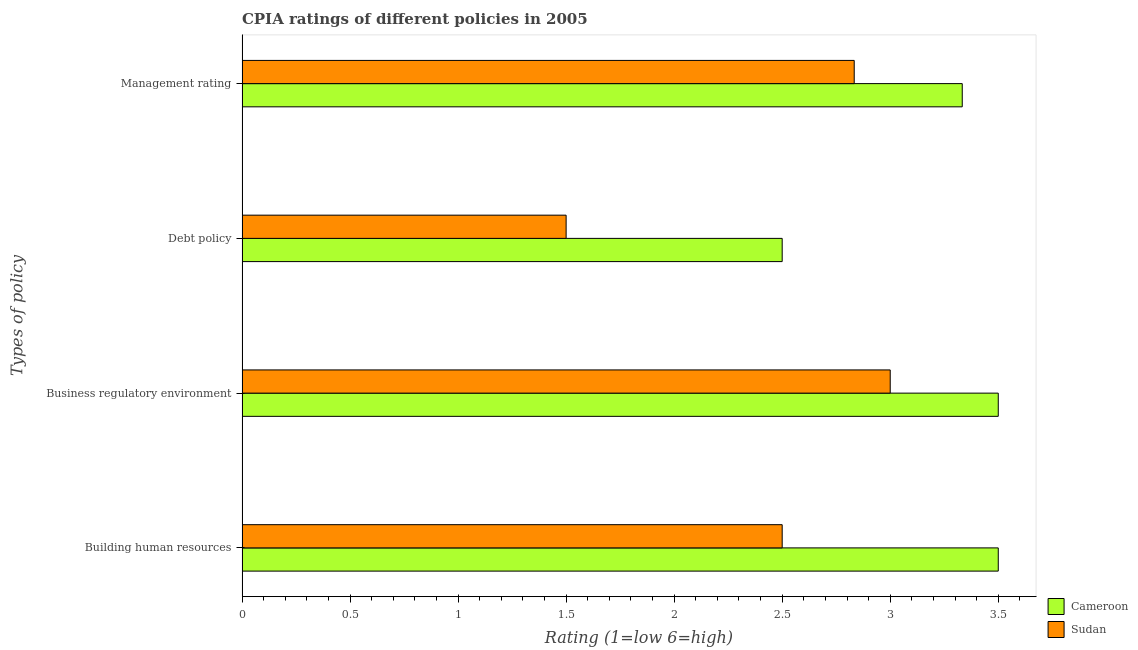How many different coloured bars are there?
Your answer should be very brief. 2. How many groups of bars are there?
Keep it short and to the point. 4. What is the label of the 3rd group of bars from the top?
Offer a terse response. Business regulatory environment. What is the cpia rating of debt policy in Cameroon?
Your response must be concise. 2.5. Across all countries, what is the maximum cpia rating of debt policy?
Offer a very short reply. 2.5. Across all countries, what is the minimum cpia rating of building human resources?
Ensure brevity in your answer.  2.5. In which country was the cpia rating of business regulatory environment maximum?
Your answer should be compact. Cameroon. In which country was the cpia rating of debt policy minimum?
Give a very brief answer. Sudan. What is the total cpia rating of business regulatory environment in the graph?
Provide a succinct answer. 6.5. What is the difference between the cpia rating of business regulatory environment in Sudan and that in Cameroon?
Make the answer very short. -0.5. What is the difference between the cpia rating of management in Sudan and the cpia rating of business regulatory environment in Cameroon?
Provide a succinct answer. -0.67. What is the average cpia rating of business regulatory environment per country?
Offer a very short reply. 3.25. In how many countries, is the cpia rating of business regulatory environment greater than 1.5 ?
Offer a terse response. 2. What is the ratio of the cpia rating of building human resources in Sudan to that in Cameroon?
Your response must be concise. 0.71. Is the difference between the cpia rating of management in Cameroon and Sudan greater than the difference between the cpia rating of debt policy in Cameroon and Sudan?
Give a very brief answer. No. What is the difference between the highest and the second highest cpia rating of business regulatory environment?
Offer a terse response. 0.5. What is the difference between the highest and the lowest cpia rating of building human resources?
Give a very brief answer. 1. Is the sum of the cpia rating of management in Cameroon and Sudan greater than the maximum cpia rating of business regulatory environment across all countries?
Your response must be concise. Yes. Is it the case that in every country, the sum of the cpia rating of management and cpia rating of business regulatory environment is greater than the sum of cpia rating of building human resources and cpia rating of debt policy?
Give a very brief answer. Yes. What does the 1st bar from the top in Business regulatory environment represents?
Your response must be concise. Sudan. What does the 1st bar from the bottom in Building human resources represents?
Ensure brevity in your answer.  Cameroon. How many countries are there in the graph?
Make the answer very short. 2. What is the difference between two consecutive major ticks on the X-axis?
Ensure brevity in your answer.  0.5. Are the values on the major ticks of X-axis written in scientific E-notation?
Give a very brief answer. No. Does the graph contain grids?
Provide a succinct answer. No. How are the legend labels stacked?
Your answer should be very brief. Vertical. What is the title of the graph?
Keep it short and to the point. CPIA ratings of different policies in 2005. What is the label or title of the Y-axis?
Ensure brevity in your answer.  Types of policy. What is the Rating (1=low 6=high) of Cameroon in Building human resources?
Provide a succinct answer. 3.5. What is the Rating (1=low 6=high) of Sudan in Building human resources?
Give a very brief answer. 2.5. What is the Rating (1=low 6=high) in Cameroon in Business regulatory environment?
Provide a succinct answer. 3.5. What is the Rating (1=low 6=high) of Cameroon in Debt policy?
Provide a succinct answer. 2.5. What is the Rating (1=low 6=high) in Sudan in Debt policy?
Give a very brief answer. 1.5. What is the Rating (1=low 6=high) in Cameroon in Management rating?
Your answer should be very brief. 3.33. What is the Rating (1=low 6=high) in Sudan in Management rating?
Provide a succinct answer. 2.83. Across all Types of policy, what is the maximum Rating (1=low 6=high) in Cameroon?
Offer a terse response. 3.5. Across all Types of policy, what is the minimum Rating (1=low 6=high) in Cameroon?
Offer a terse response. 2.5. Across all Types of policy, what is the minimum Rating (1=low 6=high) in Sudan?
Offer a terse response. 1.5. What is the total Rating (1=low 6=high) in Cameroon in the graph?
Ensure brevity in your answer.  12.83. What is the total Rating (1=low 6=high) of Sudan in the graph?
Provide a short and direct response. 9.83. What is the difference between the Rating (1=low 6=high) of Cameroon in Building human resources and that in Business regulatory environment?
Provide a succinct answer. 0. What is the difference between the Rating (1=low 6=high) in Cameroon in Building human resources and that in Management rating?
Provide a short and direct response. 0.17. What is the difference between the Rating (1=low 6=high) of Sudan in Building human resources and that in Management rating?
Your response must be concise. -0.33. What is the difference between the Rating (1=low 6=high) in Cameroon in Business regulatory environment and that in Debt policy?
Keep it short and to the point. 1. What is the difference between the Rating (1=low 6=high) of Sudan in Business regulatory environment and that in Debt policy?
Offer a terse response. 1.5. What is the difference between the Rating (1=low 6=high) in Cameroon in Business regulatory environment and that in Management rating?
Your answer should be very brief. 0.17. What is the difference between the Rating (1=low 6=high) of Sudan in Business regulatory environment and that in Management rating?
Your response must be concise. 0.17. What is the difference between the Rating (1=low 6=high) in Sudan in Debt policy and that in Management rating?
Your answer should be very brief. -1.33. What is the difference between the Rating (1=low 6=high) in Cameroon in Building human resources and the Rating (1=low 6=high) in Sudan in Business regulatory environment?
Keep it short and to the point. 0.5. What is the difference between the Rating (1=low 6=high) of Cameroon in Building human resources and the Rating (1=low 6=high) of Sudan in Debt policy?
Keep it short and to the point. 2. What is the difference between the Rating (1=low 6=high) in Cameroon in Building human resources and the Rating (1=low 6=high) in Sudan in Management rating?
Provide a succinct answer. 0.67. What is the difference between the Rating (1=low 6=high) of Cameroon in Business regulatory environment and the Rating (1=low 6=high) of Sudan in Management rating?
Your answer should be compact. 0.67. What is the difference between the Rating (1=low 6=high) in Cameroon in Debt policy and the Rating (1=low 6=high) in Sudan in Management rating?
Offer a very short reply. -0.33. What is the average Rating (1=low 6=high) in Cameroon per Types of policy?
Your answer should be very brief. 3.21. What is the average Rating (1=low 6=high) of Sudan per Types of policy?
Ensure brevity in your answer.  2.46. What is the difference between the Rating (1=low 6=high) in Cameroon and Rating (1=low 6=high) in Sudan in Debt policy?
Your response must be concise. 1. What is the ratio of the Rating (1=low 6=high) of Cameroon in Building human resources to that in Business regulatory environment?
Offer a terse response. 1. What is the ratio of the Rating (1=low 6=high) in Cameroon in Building human resources to that in Debt policy?
Provide a short and direct response. 1.4. What is the ratio of the Rating (1=low 6=high) in Cameroon in Building human resources to that in Management rating?
Your response must be concise. 1.05. What is the ratio of the Rating (1=low 6=high) in Sudan in Building human resources to that in Management rating?
Ensure brevity in your answer.  0.88. What is the ratio of the Rating (1=low 6=high) in Sudan in Business regulatory environment to that in Debt policy?
Make the answer very short. 2. What is the ratio of the Rating (1=low 6=high) of Sudan in Business regulatory environment to that in Management rating?
Offer a terse response. 1.06. What is the ratio of the Rating (1=low 6=high) of Cameroon in Debt policy to that in Management rating?
Keep it short and to the point. 0.75. What is the ratio of the Rating (1=low 6=high) in Sudan in Debt policy to that in Management rating?
Give a very brief answer. 0.53. What is the difference between the highest and the lowest Rating (1=low 6=high) of Cameroon?
Ensure brevity in your answer.  1. What is the difference between the highest and the lowest Rating (1=low 6=high) of Sudan?
Offer a terse response. 1.5. 